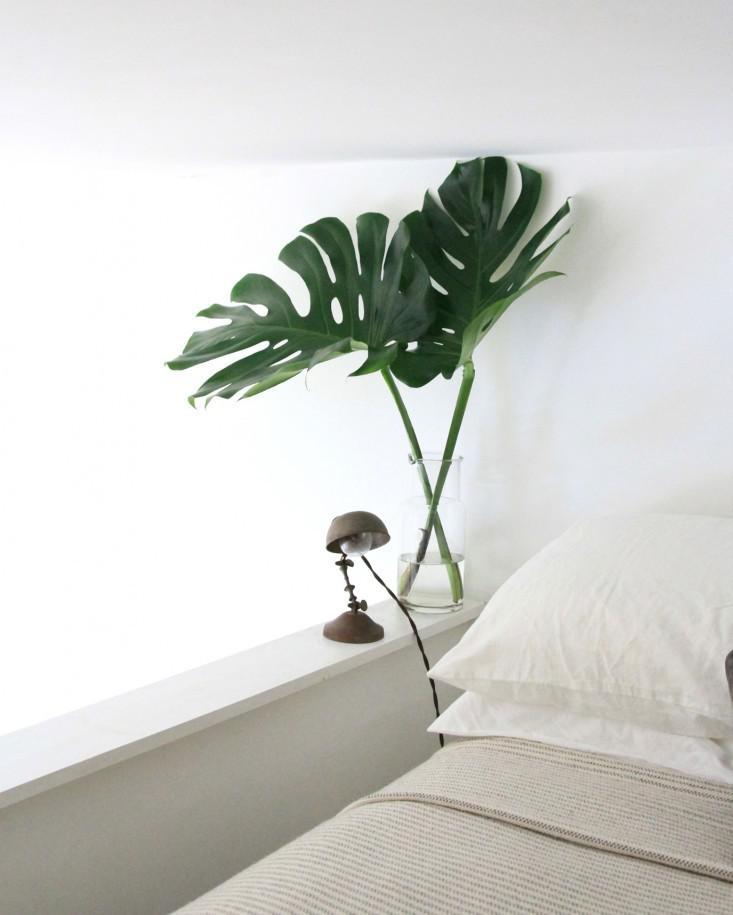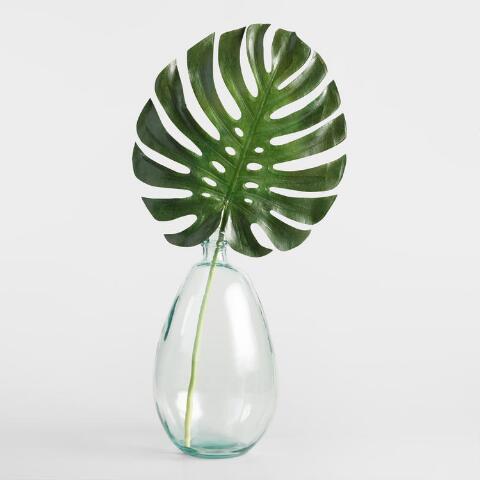The first image is the image on the left, the second image is the image on the right. Assess this claim about the two images: "The left image shows a vase containing only water and multiple leaves, and the right image features a vase with something besides water or a leaf in it.". Correct or not? Answer yes or no. No. 